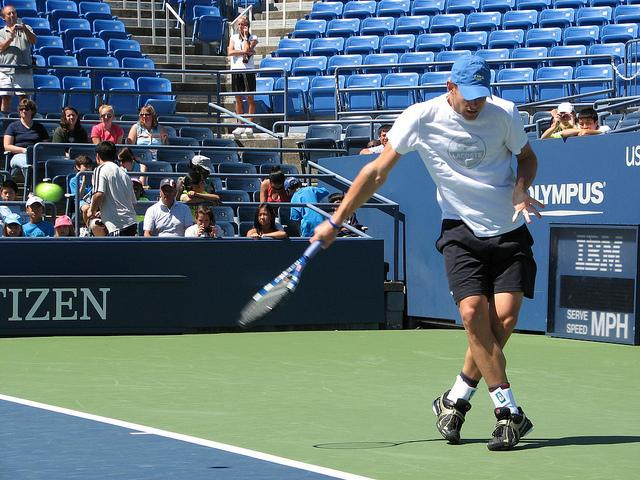What company is sponsoring the speed board? Please explain your reasoning. ibm. Behind the tennis player is a mph sign that measures speed of ball and has the logo of brand. 